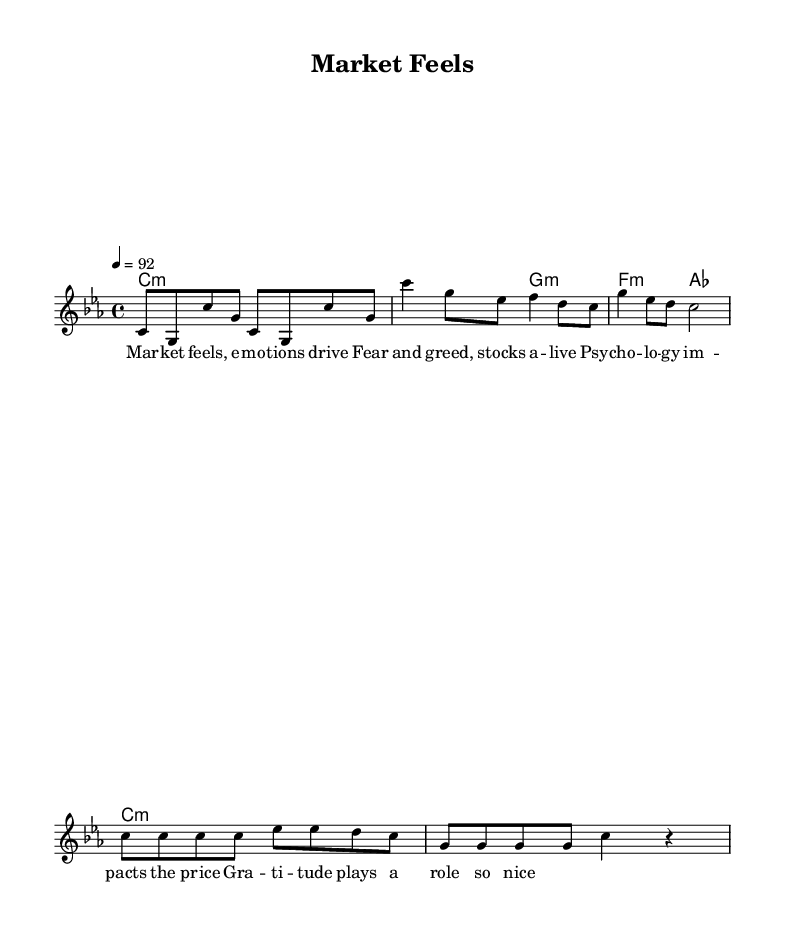What is the key signature of this music? The key signature is C minor, indicated by the presence of three flats (B flat, E flat, and A flat) in the key signature section of the sheet music.
Answer: C minor What is the time signature of this music? The time signature is 4/4, which means there are four beats per measure and a quarter note receives one beat, clearly labeled at the beginning of the score.
Answer: 4/4 What is the tempo marking for this piece? The tempo marking is indicated as quarter note equals 92, which suggests a moderate speed for the performance, provided at the beginning of the score.
Answer: 92 How many measures are in the chorus section? The chorus section consists of 4 measures, which can be counted in the melody section as there are four groups of notes structured as two lines.
Answer: 4 What emotional themes are explored in the lyrics? The lyrics explore themes of fear, greed, and gratitude as influences on economic behavior and stock market decisions, as highlighted in the phrases of the lyrics provided beneath the melody.
Answer: Fear, greed, gratitude What role does gratitude play, according to the lyrics? The lyrics suggest that gratitude has a positive role in influencing decision-making in the stock market, indicating its impact on emotional responses and economic choices.
Answer: Positive role What is the musical genre of this piece? The genre is rap, characterized by its rhythmic vocal style and thematic content that relates to economics and emotions, aligning with the structure and vocal delivery of the lyrics.
Answer: Rap 